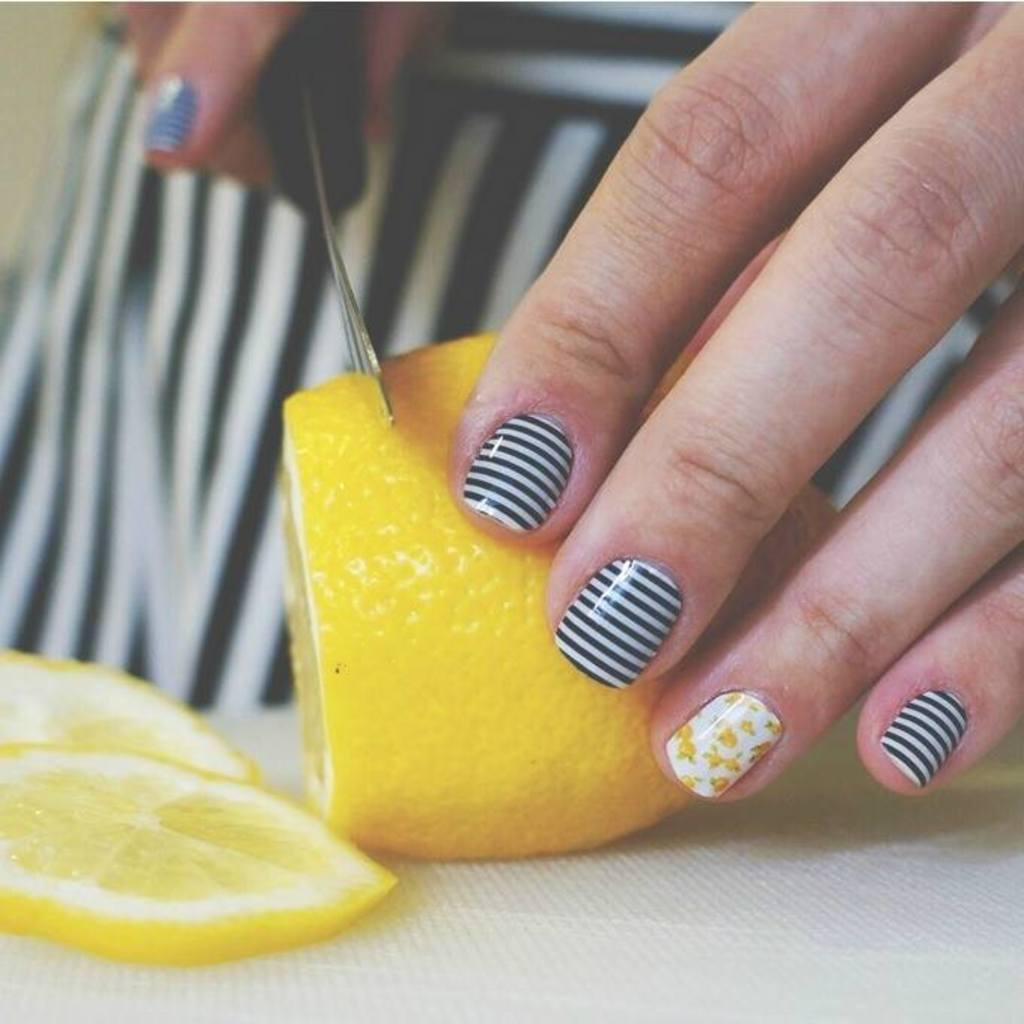Who is the main subject in the image? There is a woman in the image. What is the woman doing in the image? The woman is slicing a yellow fruit. Where is the fruit located in the image? The fruit is on a surface. What type of sack is being used to hold the fruit in the image? There is no sack present in the image; the fruit is on a surface. What type of canvas is visible in the background of the image? There is no canvas visible in the image; it only features the woman, the fruit, and the surface. 